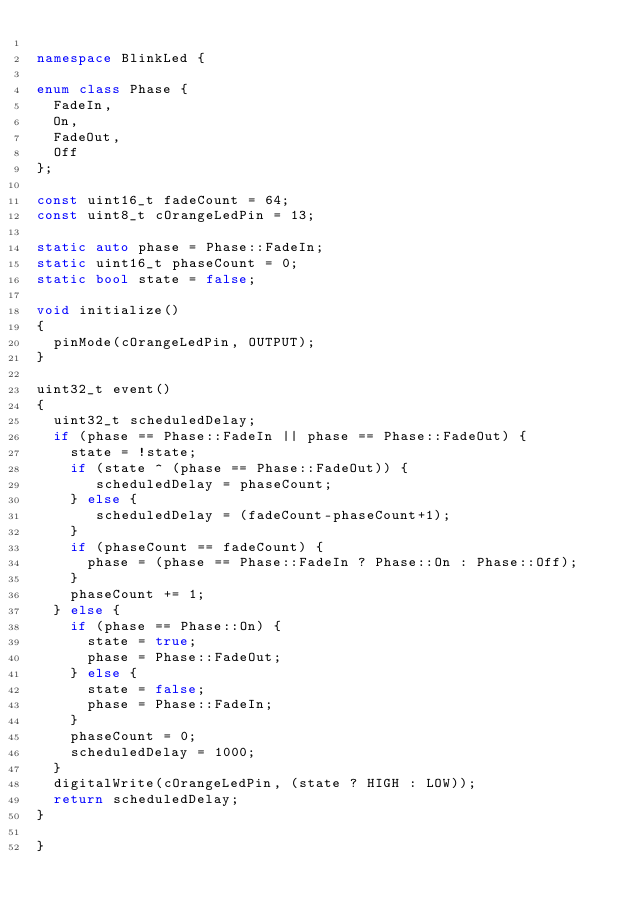<code> <loc_0><loc_0><loc_500><loc_500><_C++_>
namespace BlinkLed {

enum class Phase {
  FadeIn,
  On,
  FadeOut,
  Off
};

const uint16_t fadeCount = 64;
const uint8_t cOrangeLedPin = 13;

static auto phase = Phase::FadeIn;
static uint16_t phaseCount = 0;
static bool state = false;

void initialize()
{
  pinMode(cOrangeLedPin, OUTPUT);
}

uint32_t event()
{
  uint32_t scheduledDelay;
  if (phase == Phase::FadeIn || phase == Phase::FadeOut) {
    state = !state;
    if (state ^ (phase == Phase::FadeOut)) {
       scheduledDelay = phaseCount;
    } else {
       scheduledDelay = (fadeCount-phaseCount+1);      
    }
    if (phaseCount == fadeCount) {
      phase = (phase == Phase::FadeIn ? Phase::On : Phase::Off);
    }
    phaseCount += 1;
  } else {
    if (phase == Phase::On) {
      state = true;
      phase = Phase::FadeOut;
    } else {
      state = false;
      phase = Phase::FadeIn;
    }
    phaseCount = 0;
    scheduledDelay = 1000;          
  }
  digitalWrite(cOrangeLedPin, (state ? HIGH : LOW));
  return scheduledDelay;
}
  
}
</code> 